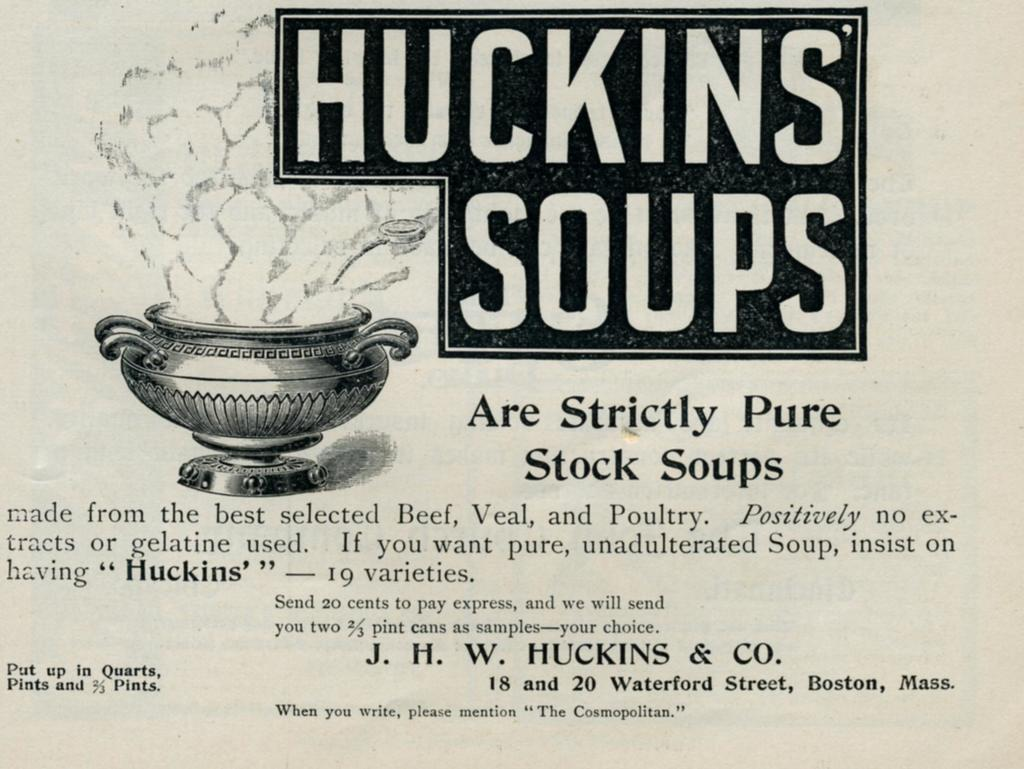What colors are used in the poster in the image? The poster is black and white. What image is depicted on the poster? There is a picture of a pot on the poster. What else is featured on the poster besides the image? There are letters on the poster. How many pizzas are depicted on the poster? There are no pizzas depicted on the poster; it features a picture of a pot. What type of connection is shown between the pot and the letters on the poster? There is no specific connection shown between the pot and the letters on the poster; they are simply elements on the same poster. 